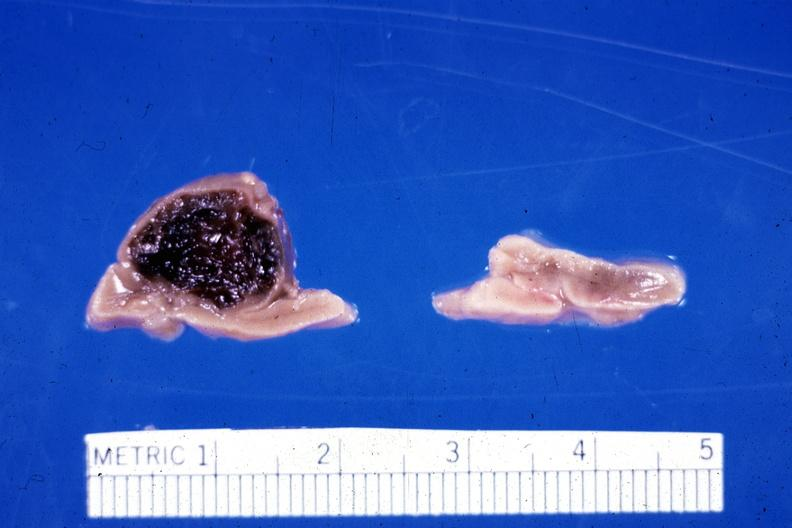how many ml had adrenal of premature 30 week gestation gram infant lesion ruptured causing hemoperitoneum?
Answer the question using a single word or phrase. Adrenal 